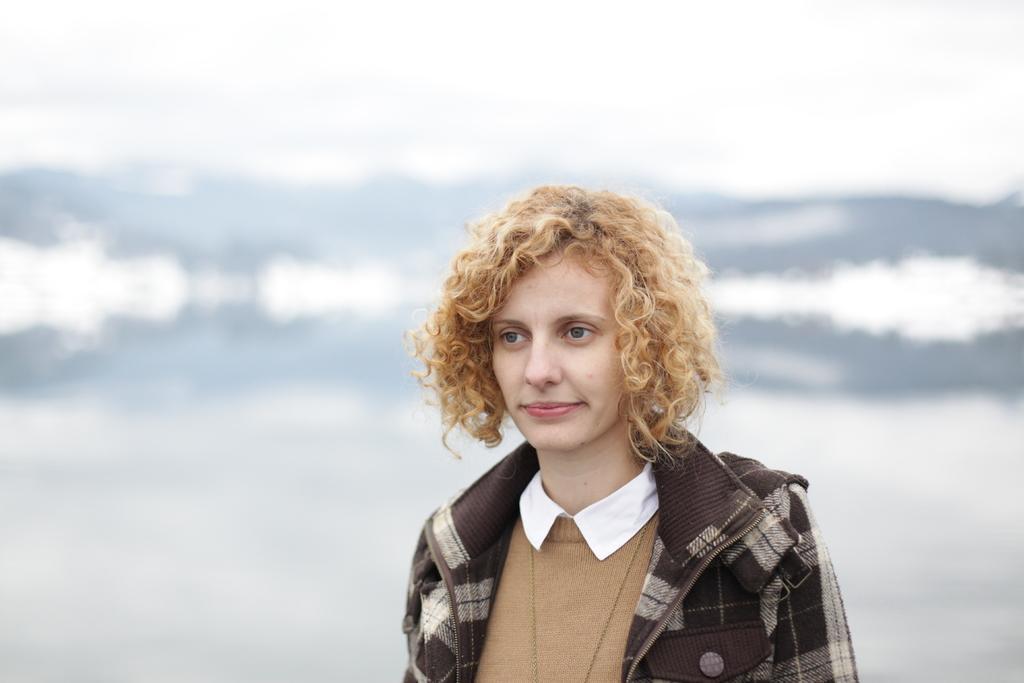Could you give a brief overview of what you see in this image? In this picture there is a woman who is wearing jacket and t-shirt. She is smiling. At the back i can see the blur background. 